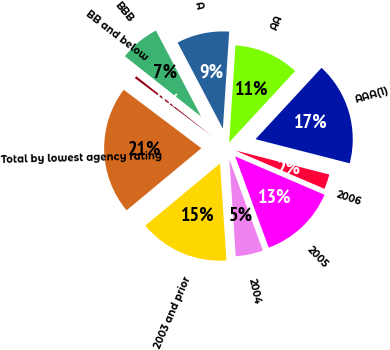Convert chart to OTSL. <chart><loc_0><loc_0><loc_500><loc_500><pie_chart><fcel>AAA(1)<fcel>AA<fcel>A<fcel>BBB<fcel>BB and below<fcel>Total by lowest agency rating<fcel>2003 and prior<fcel>2004<fcel>2005<fcel>2006<nl><fcel>17.11%<fcel>10.84%<fcel>8.74%<fcel>6.65%<fcel>0.38%<fcel>21.3%<fcel>15.02%<fcel>4.56%<fcel>12.93%<fcel>2.47%<nl></chart> 